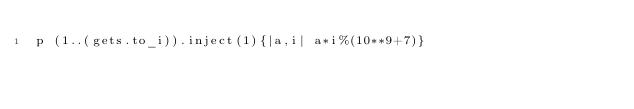<code> <loc_0><loc_0><loc_500><loc_500><_Ruby_>p (1..(gets.to_i)).inject(1){|a,i| a*i%(10**9+7)}</code> 